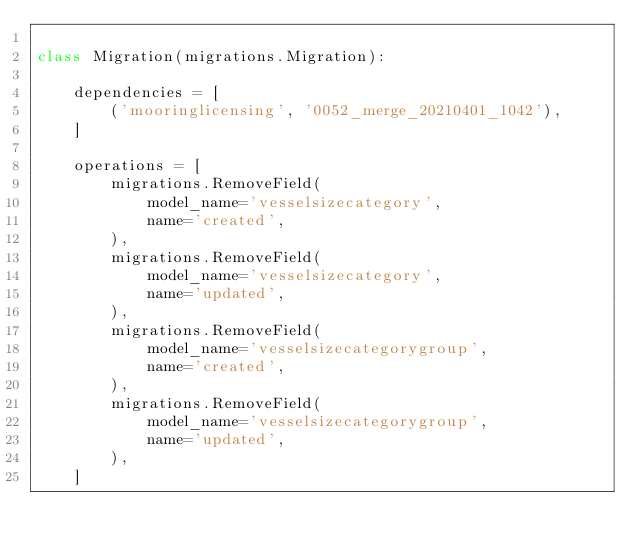<code> <loc_0><loc_0><loc_500><loc_500><_Python_>
class Migration(migrations.Migration):

    dependencies = [
        ('mooringlicensing', '0052_merge_20210401_1042'),
    ]

    operations = [
        migrations.RemoveField(
            model_name='vesselsizecategory',
            name='created',
        ),
        migrations.RemoveField(
            model_name='vesselsizecategory',
            name='updated',
        ),
        migrations.RemoveField(
            model_name='vesselsizecategorygroup',
            name='created',
        ),
        migrations.RemoveField(
            model_name='vesselsizecategorygroup',
            name='updated',
        ),
    ]
</code> 